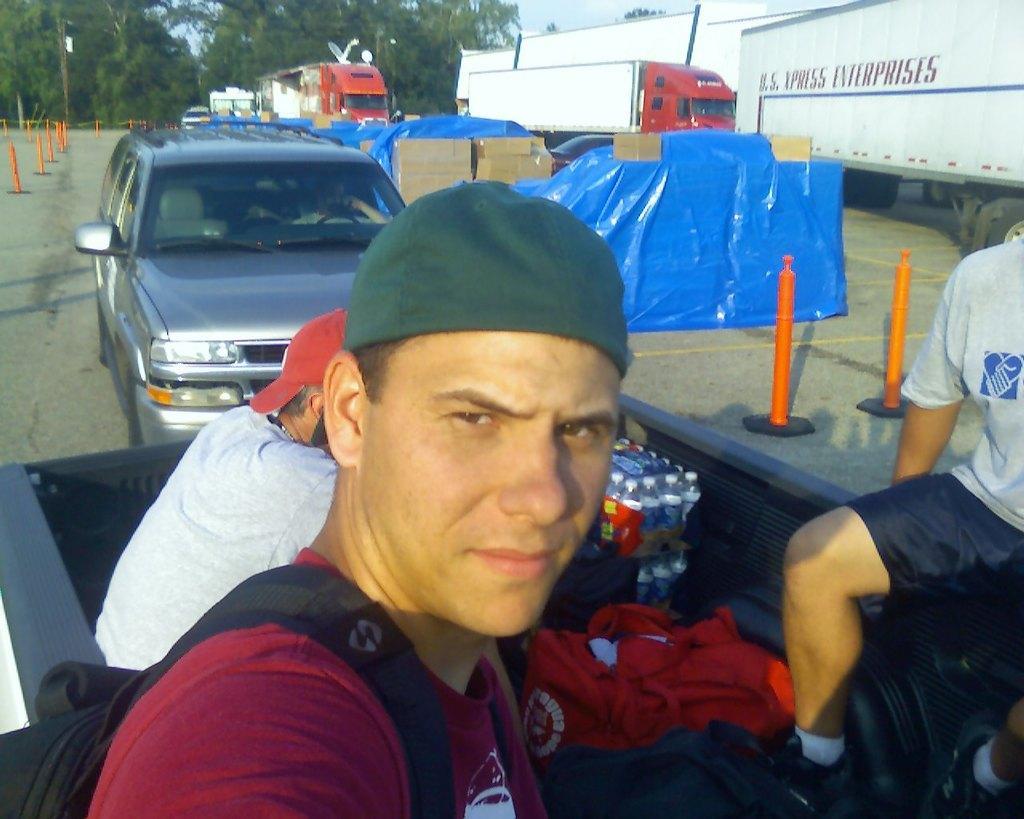Please provide a concise description of this image. This image consists of three persons. In the front, the man is holding a camera and clicking image. He is wearing red t-shirt. In the background, there is car along with boxes. To the right, there are trucks. At the bottom, there is road. 